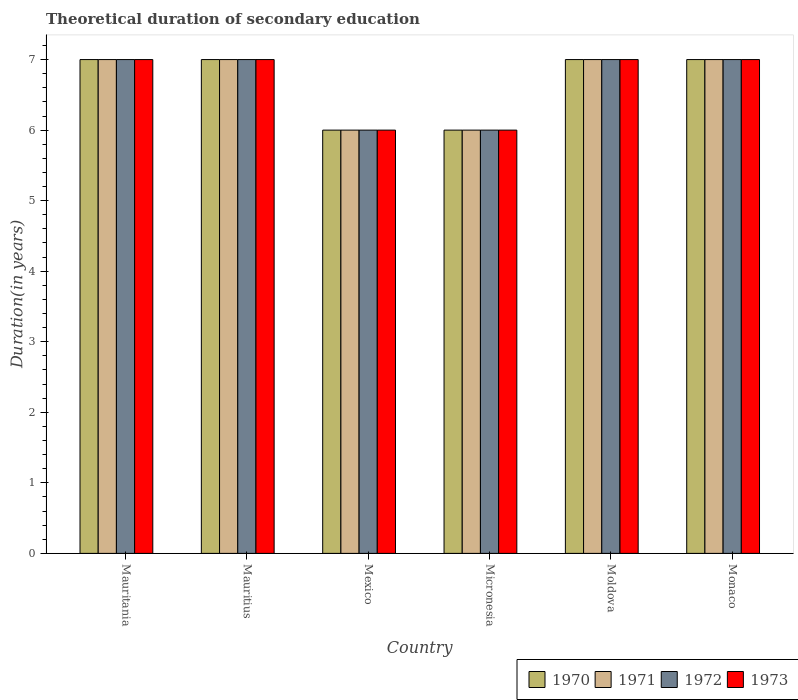Are the number of bars on each tick of the X-axis equal?
Provide a succinct answer. Yes. How many bars are there on the 5th tick from the left?
Provide a short and direct response. 4. What is the label of the 6th group of bars from the left?
Offer a very short reply. Monaco. In how many cases, is the number of bars for a given country not equal to the number of legend labels?
Make the answer very short. 0. Across all countries, what is the maximum total theoretical duration of secondary education in 1972?
Offer a terse response. 7. Across all countries, what is the minimum total theoretical duration of secondary education in 1970?
Ensure brevity in your answer.  6. In which country was the total theoretical duration of secondary education in 1972 maximum?
Your answer should be very brief. Mauritania. What is the average total theoretical duration of secondary education in 1972 per country?
Your answer should be compact. 6.67. In how many countries, is the total theoretical duration of secondary education in 1971 greater than 1.4 years?
Provide a short and direct response. 6. What does the 2nd bar from the left in Mauritius represents?
Your answer should be very brief. 1971. Is it the case that in every country, the sum of the total theoretical duration of secondary education in 1973 and total theoretical duration of secondary education in 1970 is greater than the total theoretical duration of secondary education in 1971?
Provide a succinct answer. Yes. Are all the bars in the graph horizontal?
Keep it short and to the point. No. How many countries are there in the graph?
Make the answer very short. 6. What is the difference between two consecutive major ticks on the Y-axis?
Your response must be concise. 1. Does the graph contain any zero values?
Make the answer very short. No. Where does the legend appear in the graph?
Offer a very short reply. Bottom right. How are the legend labels stacked?
Your response must be concise. Horizontal. What is the title of the graph?
Offer a very short reply. Theoretical duration of secondary education. What is the label or title of the Y-axis?
Provide a succinct answer. Duration(in years). What is the Duration(in years) of 1970 in Mauritania?
Your response must be concise. 7. What is the Duration(in years) in 1973 in Mauritania?
Your answer should be compact. 7. What is the Duration(in years) of 1970 in Mauritius?
Provide a succinct answer. 7. What is the Duration(in years) of 1972 in Mauritius?
Ensure brevity in your answer.  7. What is the Duration(in years) in 1973 in Mauritius?
Your response must be concise. 7. What is the Duration(in years) of 1970 in Mexico?
Offer a very short reply. 6. What is the Duration(in years) of 1973 in Mexico?
Ensure brevity in your answer.  6. What is the Duration(in years) in 1971 in Moldova?
Ensure brevity in your answer.  7. What is the Duration(in years) in 1970 in Monaco?
Provide a succinct answer. 7. Across all countries, what is the maximum Duration(in years) of 1970?
Your response must be concise. 7. Across all countries, what is the maximum Duration(in years) of 1971?
Give a very brief answer. 7. Across all countries, what is the minimum Duration(in years) in 1970?
Your answer should be very brief. 6. Across all countries, what is the minimum Duration(in years) in 1971?
Make the answer very short. 6. Across all countries, what is the minimum Duration(in years) of 1972?
Make the answer very short. 6. Across all countries, what is the minimum Duration(in years) of 1973?
Give a very brief answer. 6. What is the total Duration(in years) in 1970 in the graph?
Provide a succinct answer. 40. What is the total Duration(in years) of 1972 in the graph?
Provide a short and direct response. 40. What is the total Duration(in years) in 1973 in the graph?
Give a very brief answer. 40. What is the difference between the Duration(in years) of 1972 in Mauritania and that in Mauritius?
Ensure brevity in your answer.  0. What is the difference between the Duration(in years) in 1973 in Mauritania and that in Mauritius?
Your response must be concise. 0. What is the difference between the Duration(in years) of 1970 in Mauritania and that in Mexico?
Offer a very short reply. 1. What is the difference between the Duration(in years) in 1971 in Mauritania and that in Mexico?
Ensure brevity in your answer.  1. What is the difference between the Duration(in years) of 1972 in Mauritania and that in Mexico?
Provide a short and direct response. 1. What is the difference between the Duration(in years) in 1970 in Mauritania and that in Micronesia?
Your response must be concise. 1. What is the difference between the Duration(in years) of 1971 in Mauritania and that in Micronesia?
Offer a very short reply. 1. What is the difference between the Duration(in years) of 1972 in Mauritania and that in Micronesia?
Make the answer very short. 1. What is the difference between the Duration(in years) in 1973 in Mauritania and that in Moldova?
Your response must be concise. 0. What is the difference between the Duration(in years) of 1971 in Mauritania and that in Monaco?
Offer a terse response. 0. What is the difference between the Duration(in years) of 1971 in Mauritius and that in Mexico?
Provide a short and direct response. 1. What is the difference between the Duration(in years) in 1972 in Mauritius and that in Mexico?
Your answer should be very brief. 1. What is the difference between the Duration(in years) of 1973 in Mauritius and that in Mexico?
Provide a succinct answer. 1. What is the difference between the Duration(in years) of 1972 in Mauritius and that in Moldova?
Offer a terse response. 0. What is the difference between the Duration(in years) in 1973 in Mauritius and that in Moldova?
Give a very brief answer. 0. What is the difference between the Duration(in years) in 1970 in Mauritius and that in Monaco?
Offer a terse response. 0. What is the difference between the Duration(in years) of 1971 in Mauritius and that in Monaco?
Give a very brief answer. 0. What is the difference between the Duration(in years) in 1973 in Mauritius and that in Monaco?
Offer a very short reply. 0. What is the difference between the Duration(in years) in 1970 in Mexico and that in Micronesia?
Offer a terse response. 0. What is the difference between the Duration(in years) in 1970 in Mexico and that in Moldova?
Ensure brevity in your answer.  -1. What is the difference between the Duration(in years) of 1971 in Mexico and that in Monaco?
Your answer should be very brief. -1. What is the difference between the Duration(in years) in 1972 in Mexico and that in Monaco?
Your response must be concise. -1. What is the difference between the Duration(in years) of 1970 in Micronesia and that in Moldova?
Give a very brief answer. -1. What is the difference between the Duration(in years) in 1971 in Micronesia and that in Moldova?
Your response must be concise. -1. What is the difference between the Duration(in years) in 1972 in Micronesia and that in Moldova?
Offer a very short reply. -1. What is the difference between the Duration(in years) of 1972 in Micronesia and that in Monaco?
Make the answer very short. -1. What is the difference between the Duration(in years) in 1970 in Moldova and that in Monaco?
Ensure brevity in your answer.  0. What is the difference between the Duration(in years) in 1973 in Moldova and that in Monaco?
Your answer should be compact. 0. What is the difference between the Duration(in years) in 1970 in Mauritania and the Duration(in years) in 1971 in Mauritius?
Provide a short and direct response. 0. What is the difference between the Duration(in years) of 1970 in Mauritania and the Duration(in years) of 1973 in Mauritius?
Provide a succinct answer. 0. What is the difference between the Duration(in years) of 1971 in Mauritania and the Duration(in years) of 1973 in Mauritius?
Provide a short and direct response. 0. What is the difference between the Duration(in years) in 1972 in Mauritania and the Duration(in years) in 1973 in Mauritius?
Ensure brevity in your answer.  0. What is the difference between the Duration(in years) in 1970 in Mauritania and the Duration(in years) in 1972 in Mexico?
Your answer should be very brief. 1. What is the difference between the Duration(in years) in 1971 in Mauritania and the Duration(in years) in 1972 in Mexico?
Offer a very short reply. 1. What is the difference between the Duration(in years) in 1970 in Mauritania and the Duration(in years) in 1973 in Micronesia?
Provide a succinct answer. 1. What is the difference between the Duration(in years) of 1971 in Mauritania and the Duration(in years) of 1972 in Micronesia?
Give a very brief answer. 1. What is the difference between the Duration(in years) of 1972 in Mauritania and the Duration(in years) of 1973 in Micronesia?
Your response must be concise. 1. What is the difference between the Duration(in years) in 1970 in Mauritania and the Duration(in years) in 1972 in Moldova?
Offer a terse response. 0. What is the difference between the Duration(in years) of 1970 in Mauritania and the Duration(in years) of 1973 in Moldova?
Make the answer very short. 0. What is the difference between the Duration(in years) in 1971 in Mauritania and the Duration(in years) in 1973 in Moldova?
Make the answer very short. 0. What is the difference between the Duration(in years) of 1970 in Mauritania and the Duration(in years) of 1971 in Monaco?
Offer a terse response. 0. What is the difference between the Duration(in years) of 1970 in Mauritania and the Duration(in years) of 1972 in Monaco?
Provide a succinct answer. 0. What is the difference between the Duration(in years) of 1970 in Mauritania and the Duration(in years) of 1973 in Monaco?
Provide a succinct answer. 0. What is the difference between the Duration(in years) of 1971 in Mauritania and the Duration(in years) of 1972 in Monaco?
Provide a short and direct response. 0. What is the difference between the Duration(in years) of 1971 in Mauritania and the Duration(in years) of 1973 in Monaco?
Keep it short and to the point. 0. What is the difference between the Duration(in years) in 1972 in Mauritania and the Duration(in years) in 1973 in Monaco?
Give a very brief answer. 0. What is the difference between the Duration(in years) of 1970 in Mauritius and the Duration(in years) of 1971 in Mexico?
Provide a succinct answer. 1. What is the difference between the Duration(in years) of 1970 in Mauritius and the Duration(in years) of 1973 in Mexico?
Your answer should be very brief. 1. What is the difference between the Duration(in years) of 1970 in Mauritius and the Duration(in years) of 1972 in Micronesia?
Offer a very short reply. 1. What is the difference between the Duration(in years) of 1970 in Mauritius and the Duration(in years) of 1973 in Micronesia?
Offer a very short reply. 1. What is the difference between the Duration(in years) in 1971 in Mauritius and the Duration(in years) in 1972 in Micronesia?
Keep it short and to the point. 1. What is the difference between the Duration(in years) in 1970 in Mauritius and the Duration(in years) in 1973 in Moldova?
Provide a short and direct response. 0. What is the difference between the Duration(in years) in 1971 in Mauritius and the Duration(in years) in 1972 in Moldova?
Your answer should be very brief. 0. What is the difference between the Duration(in years) in 1972 in Mauritius and the Duration(in years) in 1973 in Moldova?
Offer a very short reply. 0. What is the difference between the Duration(in years) of 1970 in Mauritius and the Duration(in years) of 1971 in Monaco?
Make the answer very short. 0. What is the difference between the Duration(in years) of 1970 in Mauritius and the Duration(in years) of 1972 in Monaco?
Give a very brief answer. 0. What is the difference between the Duration(in years) of 1970 in Mauritius and the Duration(in years) of 1973 in Monaco?
Provide a short and direct response. 0. What is the difference between the Duration(in years) in 1971 in Mauritius and the Duration(in years) in 1972 in Monaco?
Make the answer very short. 0. What is the difference between the Duration(in years) of 1971 in Mauritius and the Duration(in years) of 1973 in Monaco?
Your answer should be compact. 0. What is the difference between the Duration(in years) of 1970 in Mexico and the Duration(in years) of 1973 in Micronesia?
Give a very brief answer. 0. What is the difference between the Duration(in years) of 1971 in Mexico and the Duration(in years) of 1972 in Micronesia?
Give a very brief answer. 0. What is the difference between the Duration(in years) in 1972 in Mexico and the Duration(in years) in 1973 in Micronesia?
Ensure brevity in your answer.  0. What is the difference between the Duration(in years) in 1970 in Mexico and the Duration(in years) in 1972 in Moldova?
Ensure brevity in your answer.  -1. What is the difference between the Duration(in years) in 1970 in Mexico and the Duration(in years) in 1973 in Moldova?
Ensure brevity in your answer.  -1. What is the difference between the Duration(in years) in 1971 in Mexico and the Duration(in years) in 1972 in Moldova?
Your answer should be very brief. -1. What is the difference between the Duration(in years) in 1971 in Mexico and the Duration(in years) in 1973 in Moldova?
Your answer should be compact. -1. What is the difference between the Duration(in years) in 1970 in Mexico and the Duration(in years) in 1971 in Monaco?
Keep it short and to the point. -1. What is the difference between the Duration(in years) of 1970 in Mexico and the Duration(in years) of 1972 in Monaco?
Offer a terse response. -1. What is the difference between the Duration(in years) of 1970 in Mexico and the Duration(in years) of 1973 in Monaco?
Make the answer very short. -1. What is the difference between the Duration(in years) in 1971 in Mexico and the Duration(in years) in 1972 in Monaco?
Your response must be concise. -1. What is the difference between the Duration(in years) in 1971 in Mexico and the Duration(in years) in 1973 in Monaco?
Your response must be concise. -1. What is the difference between the Duration(in years) in 1970 in Micronesia and the Duration(in years) in 1971 in Moldova?
Offer a terse response. -1. What is the difference between the Duration(in years) of 1972 in Micronesia and the Duration(in years) of 1973 in Moldova?
Your answer should be compact. -1. What is the difference between the Duration(in years) of 1972 in Micronesia and the Duration(in years) of 1973 in Monaco?
Offer a terse response. -1. What is the difference between the Duration(in years) in 1970 in Moldova and the Duration(in years) in 1973 in Monaco?
Offer a very short reply. 0. What is the difference between the Duration(in years) in 1971 in Moldova and the Duration(in years) in 1972 in Monaco?
Offer a terse response. 0. What is the difference between the Duration(in years) in 1972 in Moldova and the Duration(in years) in 1973 in Monaco?
Your response must be concise. 0. What is the average Duration(in years) of 1971 per country?
Provide a succinct answer. 6.67. What is the difference between the Duration(in years) of 1970 and Duration(in years) of 1973 in Mauritania?
Your answer should be compact. 0. What is the difference between the Duration(in years) of 1971 and Duration(in years) of 1972 in Mauritania?
Offer a terse response. 0. What is the difference between the Duration(in years) in 1970 and Duration(in years) in 1971 in Mauritius?
Keep it short and to the point. 0. What is the difference between the Duration(in years) of 1970 and Duration(in years) of 1972 in Mauritius?
Keep it short and to the point. 0. What is the difference between the Duration(in years) of 1971 and Duration(in years) of 1973 in Mauritius?
Your answer should be compact. 0. What is the difference between the Duration(in years) of 1971 and Duration(in years) of 1973 in Mexico?
Keep it short and to the point. 0. What is the difference between the Duration(in years) of 1972 and Duration(in years) of 1973 in Mexico?
Provide a succinct answer. 0. What is the difference between the Duration(in years) of 1970 and Duration(in years) of 1971 in Micronesia?
Provide a short and direct response. 0. What is the difference between the Duration(in years) in 1970 and Duration(in years) in 1972 in Micronesia?
Provide a short and direct response. 0. What is the difference between the Duration(in years) of 1971 and Duration(in years) of 1972 in Micronesia?
Your response must be concise. 0. What is the difference between the Duration(in years) of 1971 and Duration(in years) of 1973 in Micronesia?
Provide a short and direct response. 0. What is the difference between the Duration(in years) in 1972 and Duration(in years) in 1973 in Micronesia?
Your response must be concise. 0. What is the difference between the Duration(in years) in 1970 and Duration(in years) in 1971 in Moldova?
Give a very brief answer. 0. What is the difference between the Duration(in years) in 1970 and Duration(in years) in 1972 in Moldova?
Make the answer very short. 0. What is the difference between the Duration(in years) of 1970 and Duration(in years) of 1973 in Moldova?
Keep it short and to the point. 0. What is the difference between the Duration(in years) of 1972 and Duration(in years) of 1973 in Moldova?
Your response must be concise. 0. What is the difference between the Duration(in years) of 1970 and Duration(in years) of 1971 in Monaco?
Provide a succinct answer. 0. What is the difference between the Duration(in years) in 1972 and Duration(in years) in 1973 in Monaco?
Make the answer very short. 0. What is the ratio of the Duration(in years) in 1972 in Mauritania to that in Mauritius?
Your response must be concise. 1. What is the ratio of the Duration(in years) in 1973 in Mauritania to that in Mauritius?
Provide a short and direct response. 1. What is the ratio of the Duration(in years) of 1970 in Mauritania to that in Mexico?
Make the answer very short. 1.17. What is the ratio of the Duration(in years) in 1971 in Mauritania to that in Mexico?
Your answer should be very brief. 1.17. What is the ratio of the Duration(in years) in 1972 in Mauritania to that in Mexico?
Your answer should be very brief. 1.17. What is the ratio of the Duration(in years) in 1970 in Mauritania to that in Micronesia?
Your answer should be very brief. 1.17. What is the ratio of the Duration(in years) in 1973 in Mauritania to that in Micronesia?
Your answer should be compact. 1.17. What is the ratio of the Duration(in years) in 1970 in Mauritania to that in Moldova?
Provide a succinct answer. 1. What is the ratio of the Duration(in years) in 1970 in Mauritania to that in Monaco?
Make the answer very short. 1. What is the ratio of the Duration(in years) of 1971 in Mauritania to that in Monaco?
Ensure brevity in your answer.  1. What is the ratio of the Duration(in years) of 1973 in Mauritania to that in Monaco?
Make the answer very short. 1. What is the ratio of the Duration(in years) of 1970 in Mauritius to that in Mexico?
Offer a very short reply. 1.17. What is the ratio of the Duration(in years) of 1972 in Mauritius to that in Mexico?
Your answer should be very brief. 1.17. What is the ratio of the Duration(in years) of 1973 in Mauritius to that in Mexico?
Ensure brevity in your answer.  1.17. What is the ratio of the Duration(in years) in 1970 in Mauritius to that in Micronesia?
Keep it short and to the point. 1.17. What is the ratio of the Duration(in years) in 1973 in Mauritius to that in Micronesia?
Provide a succinct answer. 1.17. What is the ratio of the Duration(in years) of 1970 in Mauritius to that in Moldova?
Ensure brevity in your answer.  1. What is the ratio of the Duration(in years) in 1971 in Mauritius to that in Moldova?
Your answer should be very brief. 1. What is the ratio of the Duration(in years) in 1970 in Mauritius to that in Monaco?
Make the answer very short. 1. What is the ratio of the Duration(in years) in 1971 in Mauritius to that in Monaco?
Offer a terse response. 1. What is the ratio of the Duration(in years) in 1973 in Mauritius to that in Monaco?
Make the answer very short. 1. What is the ratio of the Duration(in years) of 1970 in Mexico to that in Micronesia?
Offer a terse response. 1. What is the ratio of the Duration(in years) of 1971 in Mexico to that in Moldova?
Keep it short and to the point. 0.86. What is the ratio of the Duration(in years) in 1972 in Mexico to that in Moldova?
Keep it short and to the point. 0.86. What is the ratio of the Duration(in years) in 1972 in Mexico to that in Monaco?
Ensure brevity in your answer.  0.86. What is the ratio of the Duration(in years) of 1973 in Mexico to that in Monaco?
Offer a very short reply. 0.86. What is the ratio of the Duration(in years) in 1971 in Micronesia to that in Moldova?
Your answer should be very brief. 0.86. What is the ratio of the Duration(in years) of 1970 in Micronesia to that in Monaco?
Your answer should be compact. 0.86. What is the ratio of the Duration(in years) in 1971 in Micronesia to that in Monaco?
Your answer should be compact. 0.86. What is the ratio of the Duration(in years) in 1972 in Micronesia to that in Monaco?
Ensure brevity in your answer.  0.86. What is the ratio of the Duration(in years) of 1973 in Micronesia to that in Monaco?
Ensure brevity in your answer.  0.86. What is the ratio of the Duration(in years) of 1973 in Moldova to that in Monaco?
Provide a short and direct response. 1. What is the difference between the highest and the lowest Duration(in years) of 1970?
Offer a terse response. 1. What is the difference between the highest and the lowest Duration(in years) in 1973?
Your answer should be compact. 1. 